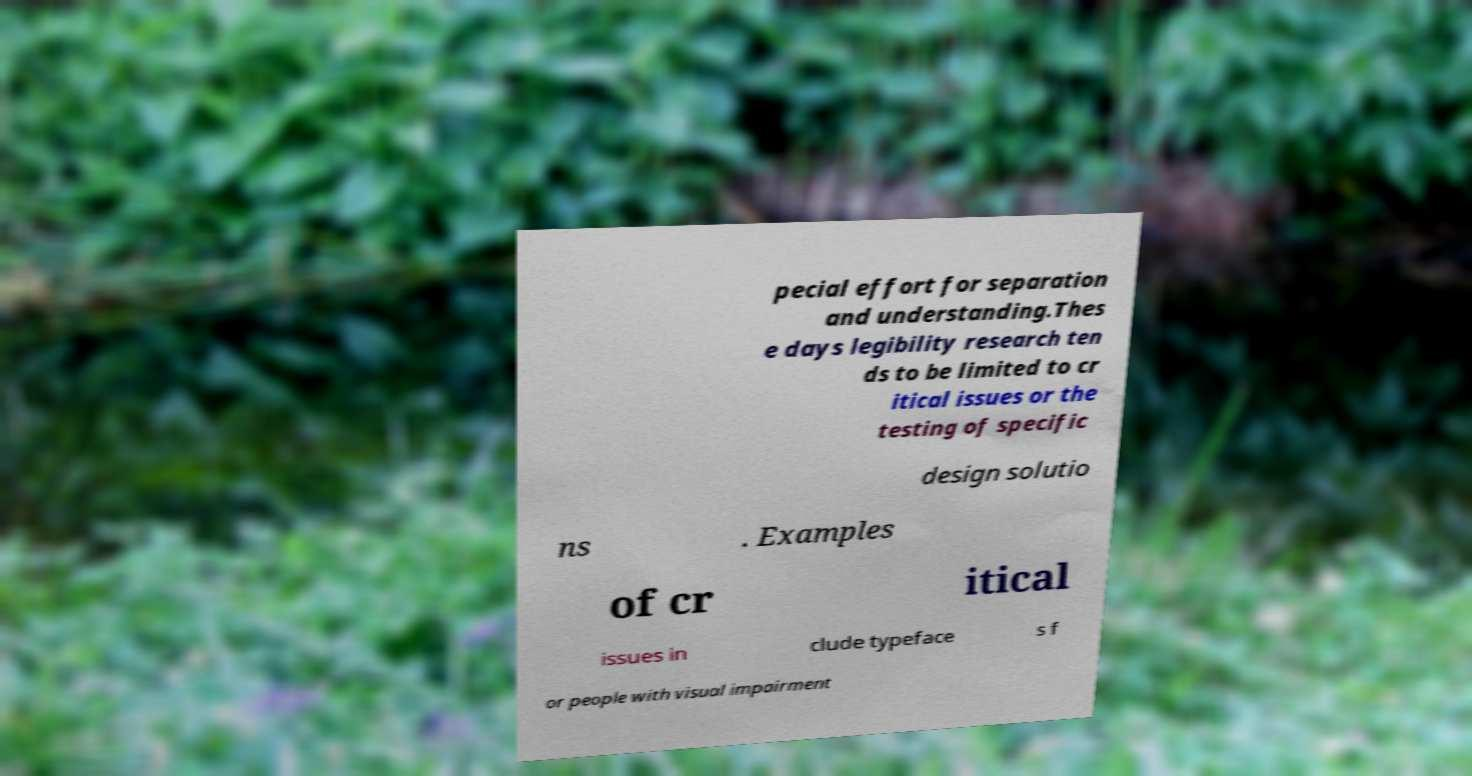Can you read and provide the text displayed in the image?This photo seems to have some interesting text. Can you extract and type it out for me? pecial effort for separation and understanding.Thes e days legibility research ten ds to be limited to cr itical issues or the testing of specific design solutio ns . Examples of cr itical issues in clude typeface s f or people with visual impairment 